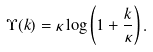Convert formula to latex. <formula><loc_0><loc_0><loc_500><loc_500>\Upsilon ( k ) = \kappa \log \left ( 1 + \frac { k } { \kappa } \right ) .</formula> 